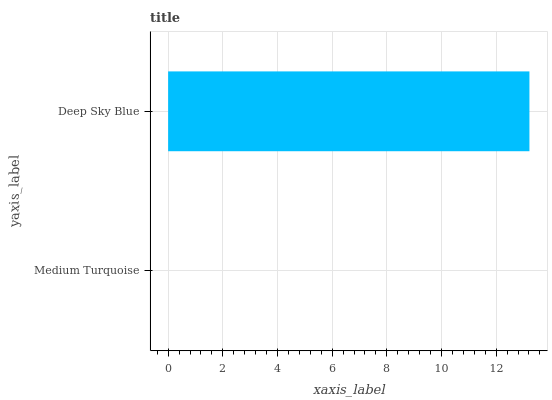Is Medium Turquoise the minimum?
Answer yes or no. Yes. Is Deep Sky Blue the maximum?
Answer yes or no. Yes. Is Deep Sky Blue the minimum?
Answer yes or no. No. Is Deep Sky Blue greater than Medium Turquoise?
Answer yes or no. Yes. Is Medium Turquoise less than Deep Sky Blue?
Answer yes or no. Yes. Is Medium Turquoise greater than Deep Sky Blue?
Answer yes or no. No. Is Deep Sky Blue less than Medium Turquoise?
Answer yes or no. No. Is Deep Sky Blue the high median?
Answer yes or no. Yes. Is Medium Turquoise the low median?
Answer yes or no. Yes. Is Medium Turquoise the high median?
Answer yes or no. No. Is Deep Sky Blue the low median?
Answer yes or no. No. 